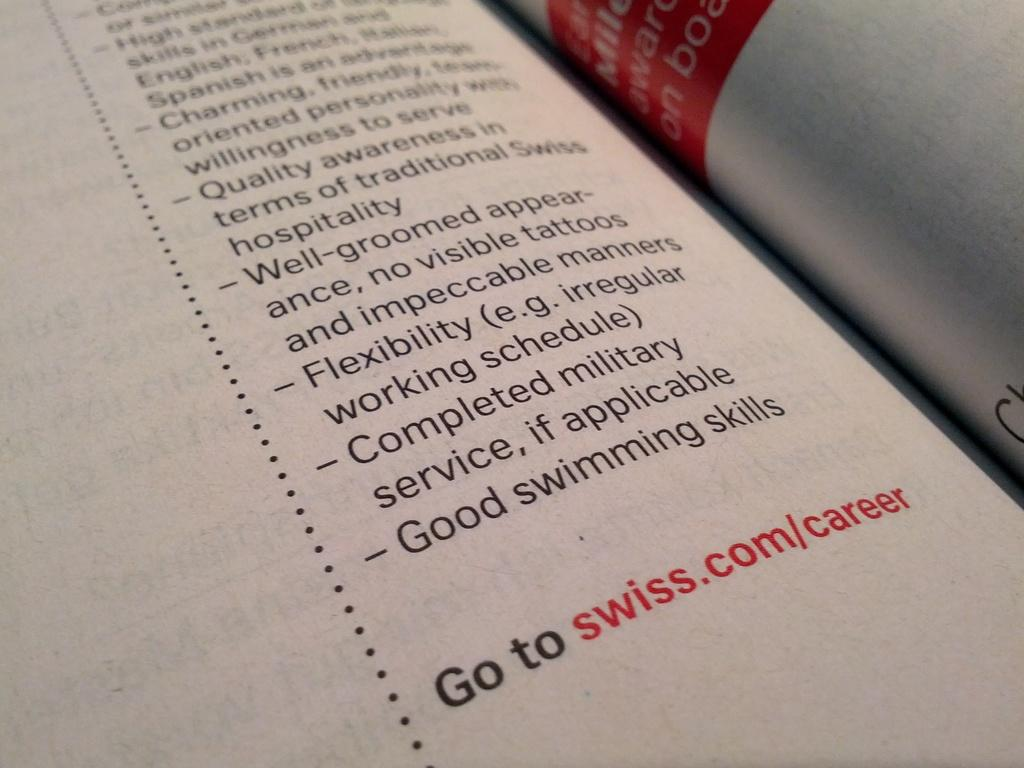<image>
Provide a brief description of the given image. A point form list about what is required to work at Swiss and you can find more at swiss.com/career. 